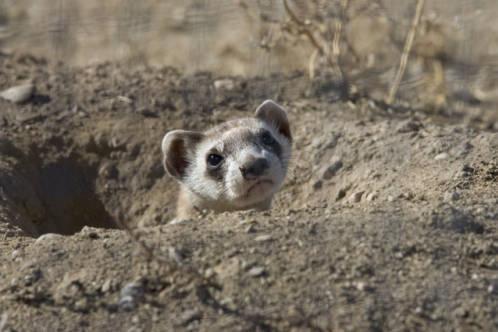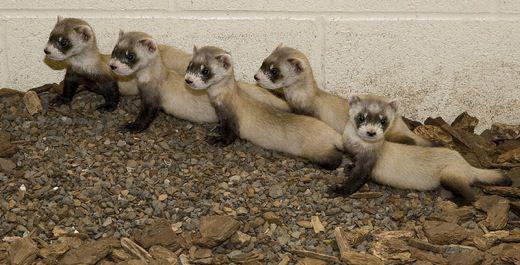The first image is the image on the left, the second image is the image on the right. For the images displayed, is the sentence "The left image shows one ferret emerging from a hole in the ground, and the right image contains multiple ferrets." factually correct? Answer yes or no. Yes. 